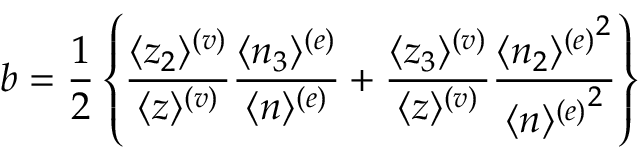Convert formula to latex. <formula><loc_0><loc_0><loc_500><loc_500>b = \frac { 1 } { 2 } \left \{ \frac { \langle z _ { 2 } \rangle ^ { ( v ) } } { \langle z \rangle ^ { ( v ) } } \frac { \langle n _ { 3 } \rangle ^ { ( e ) } } { \langle n \rangle ^ { ( e ) } } + \frac { \langle z _ { 3 } \rangle ^ { ( v ) } } { \langle z \rangle ^ { ( v ) } } \frac { { \langle n _ { 2 } \rangle ^ { ( e ) } } ^ { 2 } } { { \langle n \rangle ^ { ( e ) } } ^ { 2 } } \right \}</formula> 